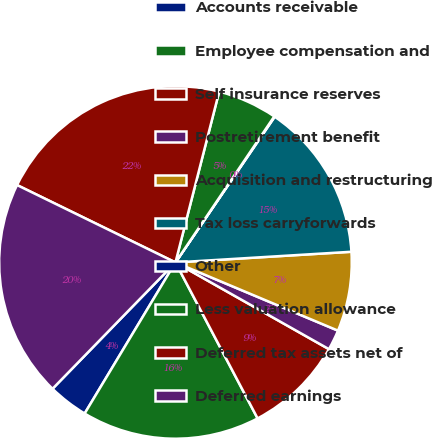Convert chart. <chart><loc_0><loc_0><loc_500><loc_500><pie_chart><fcel>Accounts receivable<fcel>Employee compensation and<fcel>Self insurance reserves<fcel>Postretirement benefit<fcel>Acquisition and restructuring<fcel>Tax loss carryforwards<fcel>Other<fcel>Less valuation allowance<fcel>Deferred tax assets net of<fcel>Deferred earnings<nl><fcel>3.67%<fcel>16.33%<fcel>9.1%<fcel>1.86%<fcel>7.29%<fcel>14.52%<fcel>0.05%<fcel>5.48%<fcel>21.76%<fcel>19.95%<nl></chart> 